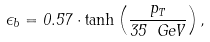Convert formula to latex. <formula><loc_0><loc_0><loc_500><loc_500>\epsilon _ { b } = 0 . 5 7 \cdot \tanh \left ( \frac { p _ { T } } { 3 5 \ G e V } \right ) ,</formula> 